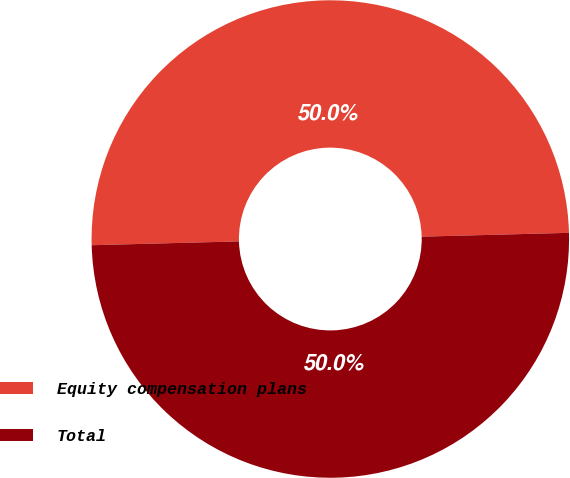Convert chart to OTSL. <chart><loc_0><loc_0><loc_500><loc_500><pie_chart><fcel>Equity compensation plans<fcel>Total<nl><fcel>50.0%<fcel>50.0%<nl></chart> 